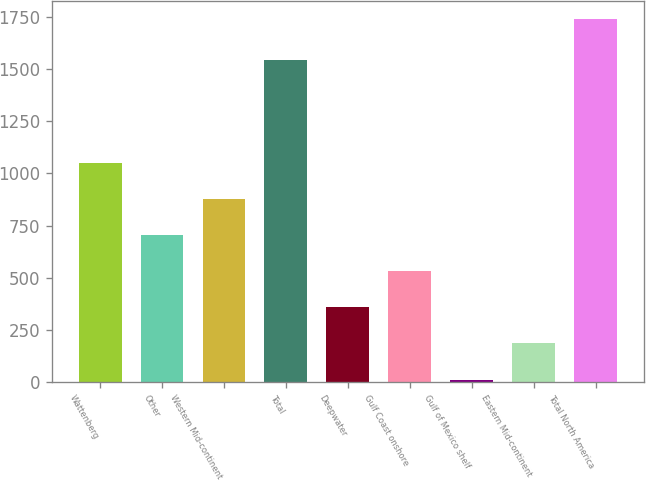<chart> <loc_0><loc_0><loc_500><loc_500><bar_chart><fcel>Wattenberg<fcel>Other<fcel>Western Mid-continent<fcel>Total<fcel>Deepwater<fcel>Gulf Coast onshore<fcel>Gulf of Mexico shelf<fcel>Eastern Mid-continent<fcel>Total North America<nl><fcel>1048.6<fcel>703.4<fcel>876<fcel>1544<fcel>358.2<fcel>530.8<fcel>13<fcel>185.6<fcel>1739<nl></chart> 